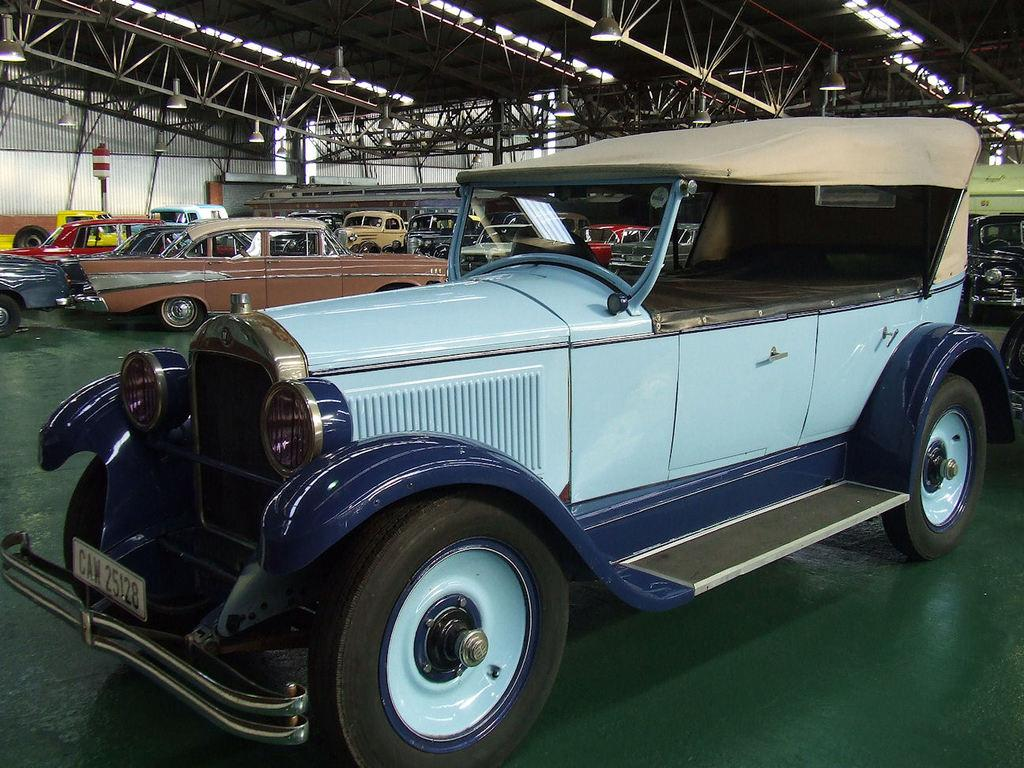What objects are on the floor in the image? There are vehicles on the floor in the image. What can be seen in the background of the image? There is a pole visible in the background of the image. What is located at the top of the image? There are rods and lights at the top of the image. What type of comfort can be found in the weight of the branch in the image? There is no branch present in the image, so it is not possible to determine any comfort related to it. 